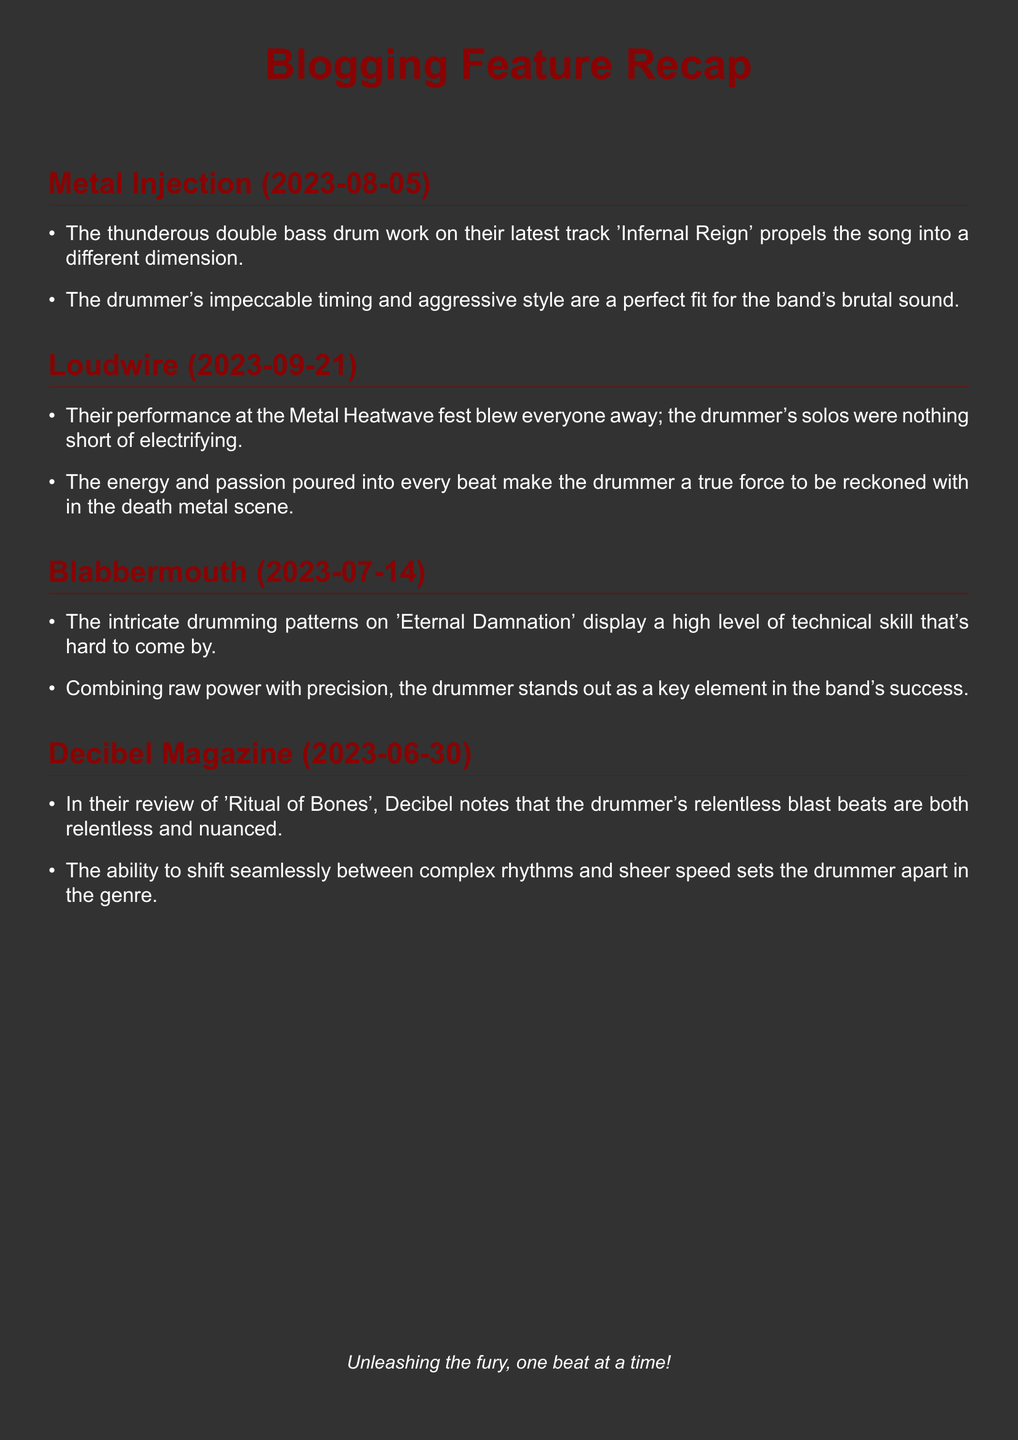What is the name of the first blog that mentioned the band? The first blog mentioned in the document is "Metal Injection."
Answer: Metal Injection What is the post date for the feature in Loudwire? The document states that the Loudwire feature was posted on September 21, 2023.
Answer: 2023-09-21 Which track's drumming was highlighted in Blabbermouth's mention? The drumming on the track 'Eternal Damnation' was highlighted in the Blabbermouth mention.
Answer: Eternal Damnation What specific aspect of the drummer's performance did Decibel Magazine focus on? Decibel Magazine focused on the drummer's relentless blast beats in their review.
Answer: Relentless blast beats How many blogs featured mentions of the band? The document lists four different blogs featuring mentions of the band.
Answer: Four What characteristic feature was noted about the drummer's style in Metal Injection? Metal Injection noted the drummer's impeccable timing and aggressive style.
Answer: Impeccable timing and aggressive style Which blog described the drummer as "a true force to be reckoned with"? Loudwire described the drummer as "a true force to be reckoned with."
Answer: Loudwire What is the overall theme of the features mentioned in the document? The overall theme highlights the drummer's skill and impact in the death metal genre.
Answer: Drummer's skill and impact 